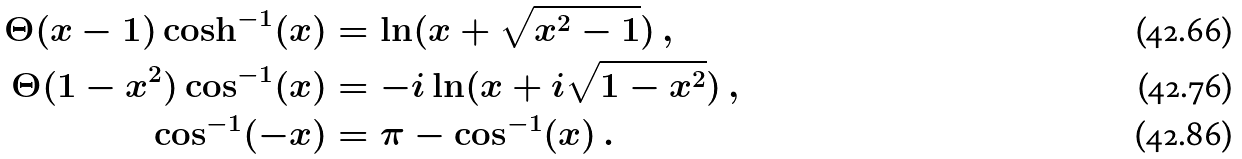Convert formula to latex. <formula><loc_0><loc_0><loc_500><loc_500>\Theta ( x - 1 ) \cosh ^ { - 1 } ( x ) & = \ln ( x + \sqrt { x ^ { 2 } - 1 } ) \, , \\ \Theta ( 1 - x ^ { 2 } ) \cos ^ { - 1 } ( x ) & = - i \ln ( x + i \sqrt { 1 - x ^ { 2 } } ) \, , \\ \cos ^ { - 1 } ( - x ) & = \pi - \cos ^ { - 1 } ( x ) \, .</formula> 